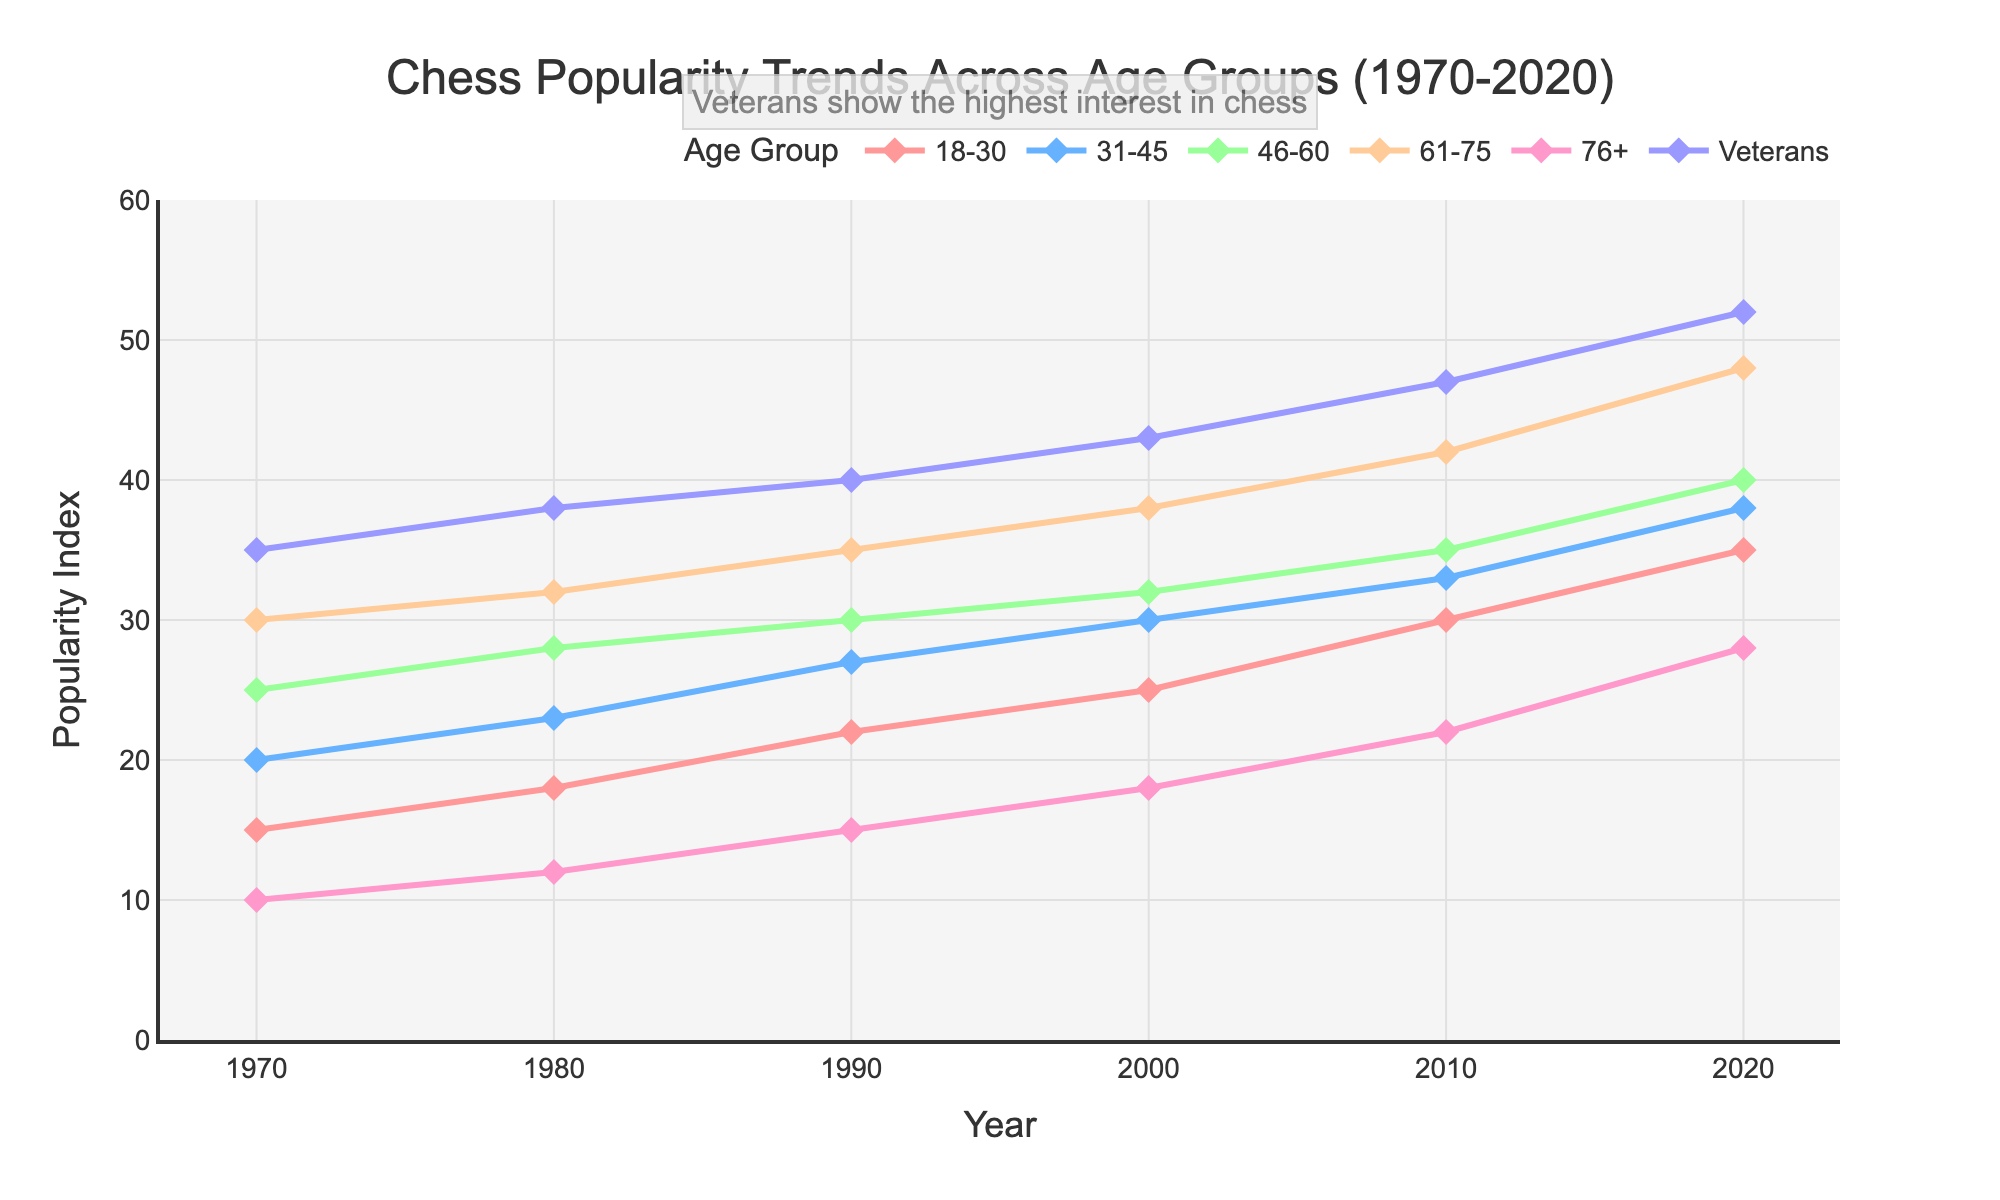What age group experienced the highest increase in chess popularity from 1970 to 2020? By looking at the initial and final values for each age group, we see that the increase is the difference between the 2020 value and the 1970 value. The increase for each group is: 18-30: 35-15 = 20, 31-45: 38-20 = 18, 46-60: 40-25 = 15, 61-75: 48-30 = 18, 76+: 28-10 = 18, Veterans: 52-35 = 17. The highest increase is for the age range 18-30.
Answer: 18-30 Which age group had the lowest chess popularity in 1970? By looking at the values for 1970, the lowest value is for the 76+ age group with a value of 10.
Answer: 76+ Between which years did the 31-45 age group see the highest increase in popularity? By looking at the trend of the 31-45 age group, we can see increases between 1970-1980 (3), 1980-1990 (4), 1990-2000 (3), 2000-2010 (3), and 2010-2020 (5). The highest increase is between 2010 and 2020.
Answer: 2010-2020 Which age group had a consistent increase in popularity across all five decades? Looking at the values for each decade for each group, the 18-30, 61-75, and Veterans groups have consistent increases. However, the Veterans group is the only one with no plateau or decrease at any point.
Answer: Veterans What was the total popularity index for the 46-60 age group over the entire period from 1970 to 2020? Summing up the popularity indices for the 46-60 age group across the years: 25 + 28 + 30 + 32 + 35 + 40 = 190.
Answer: 190 Which age group surpassed the 30 popularity index first, and in which year did it happen? Looking at the trends, the 46-60 age group surpassed 30 first in 1990, while the Veterans group already had a popularity index of 35 in 1970. Therefore, the group in the 46-60 range surpassed 30 in 1990. The year the Veterans first appear to have surpassed the 30 popularity index is not directly relevant, as it always was greater in the sample.
Answer: 46-60 In which year did the 76+ age group reach a popularity index of 15 for the first time? By looking at the trend for the 76+ age group, we can see it first reached 15 in the year 1990.
Answer: 1990 How does the popularity trend of the 31-45 age group compare to the 61-75 age group over the decades? The 31-45 age group has a consistently increasing trend but rises slower than the 61-75 group. The total increase for the 31-45 group (1970: 20, 2020: 38) is 18, whereas the 61-75 group (1970: 30, 2020: 48) has an increase of 18 as well. However, the latter reaches higher values over the decades.
Answer: 61-75 increases faster and reaches higher values Which age group was closest in popularity to the Veterans group in 2020? In 2020, the Veterans group had a popularity index of 52. The next closest group is the 61-75 age group with a popularity index of 48.
Answer: 61-75 How many age groups had a popularity index of at least 30 in the year 2020? By looking at the popularity indices for all age groups in 2020, we see that the 18-30 (35), 31-45 (38), 46-60 (40), 61-75 (48), and Veterans (52) groups all have indices above 30. Therefore, there are 5 age groups with at least a 30 index in 2020.
Answer: 5 